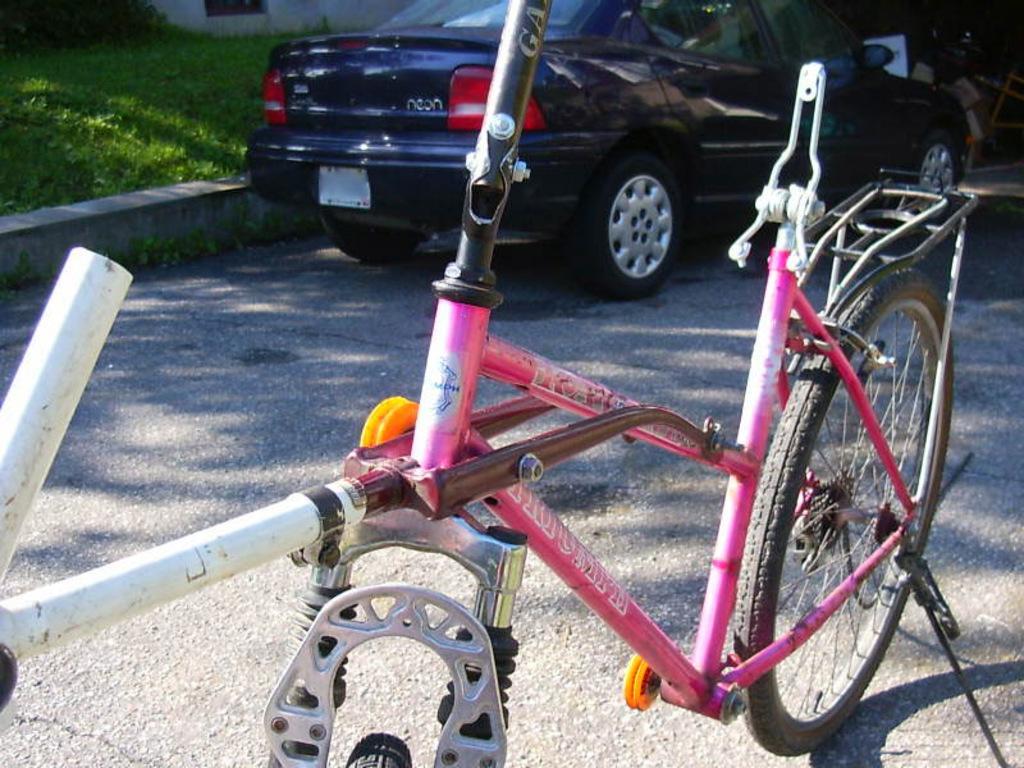Could you give a brief overview of what you see in this image? In this image I can see the bicycle and the car on the road. The bicycle is in pink color and the car is in navy blue color. To the side of the car I can see the grass and the wall. 